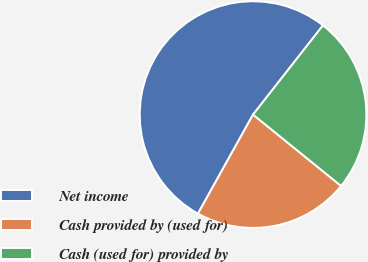Convert chart. <chart><loc_0><loc_0><loc_500><loc_500><pie_chart><fcel>Net income<fcel>Cash provided by (used for)<fcel>Cash (used for) provided by<nl><fcel>52.5%<fcel>22.24%<fcel>25.26%<nl></chart> 